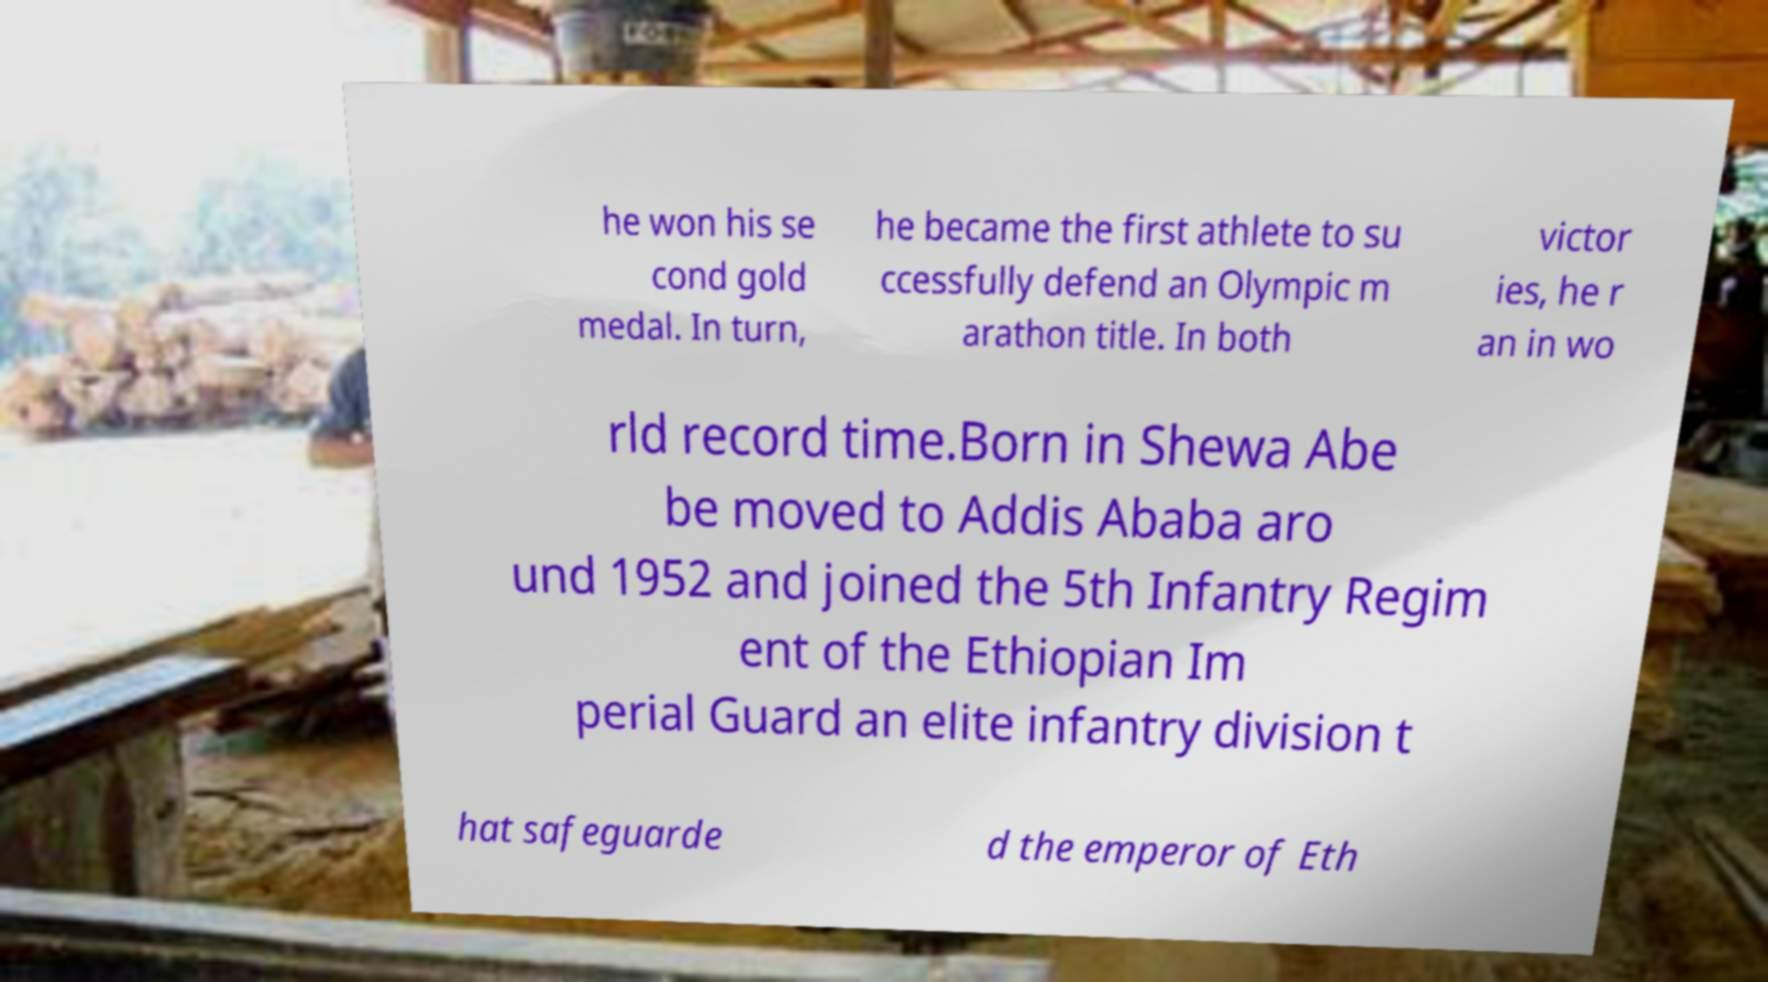Please read and relay the text visible in this image. What does it say? he won his se cond gold medal. In turn, he became the first athlete to su ccessfully defend an Olympic m arathon title. In both victor ies, he r an in wo rld record time.Born in Shewa Abe be moved to Addis Ababa aro und 1952 and joined the 5th Infantry Regim ent of the Ethiopian Im perial Guard an elite infantry division t hat safeguarde d the emperor of Eth 